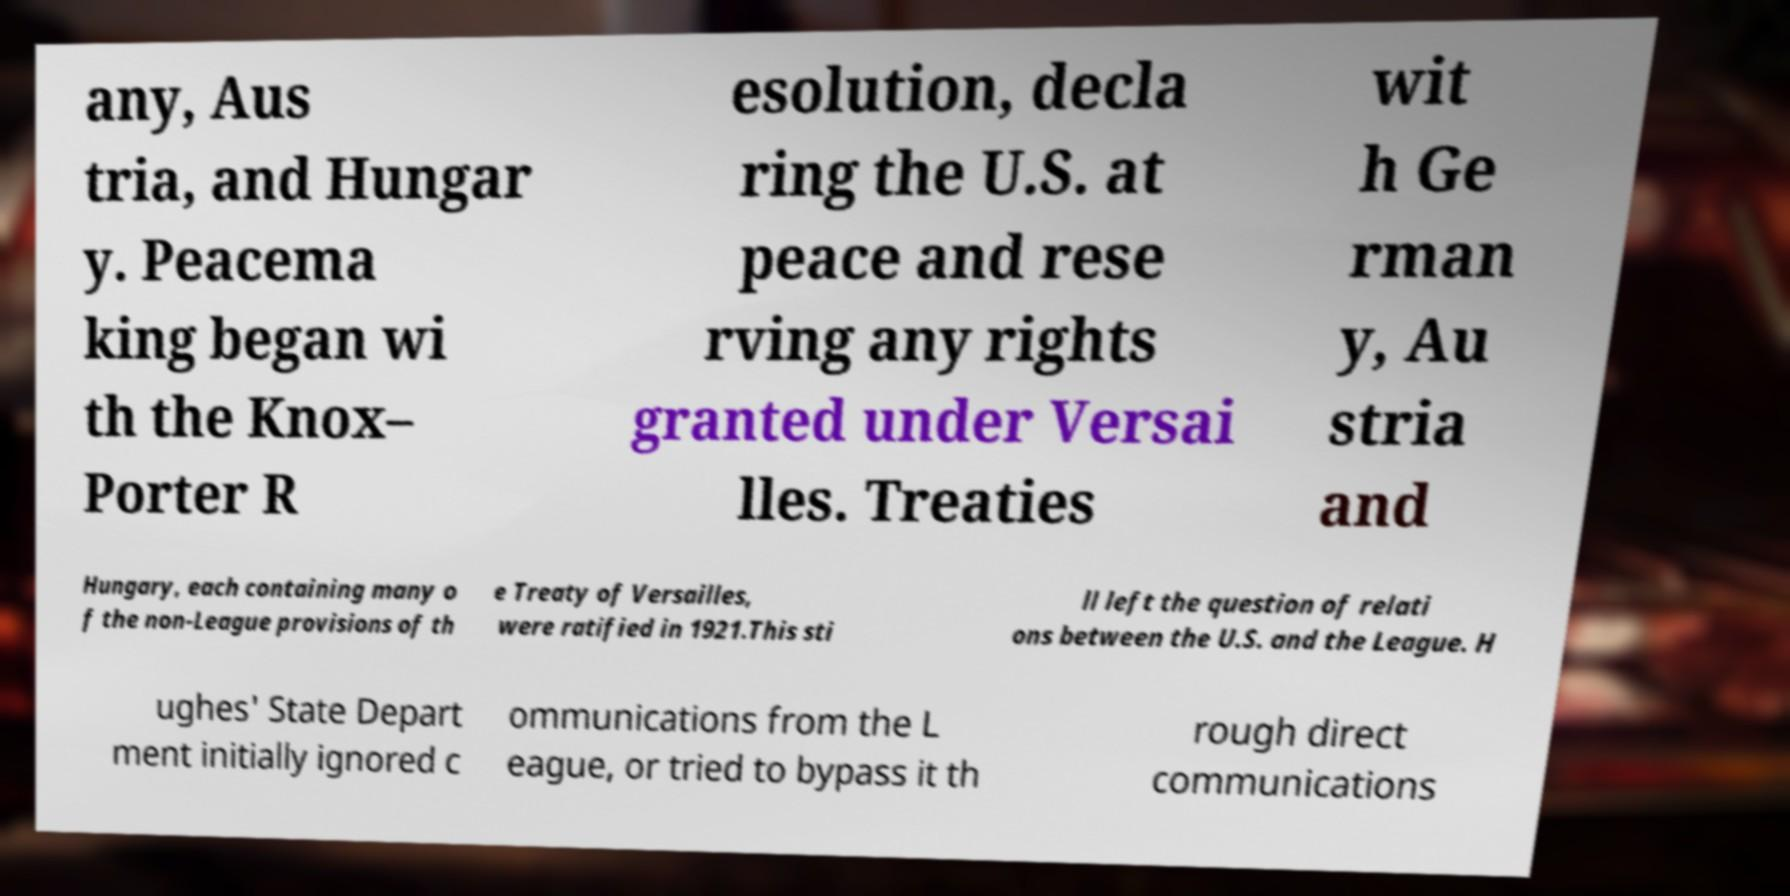I need the written content from this picture converted into text. Can you do that? any, Aus tria, and Hungar y. Peacema king began wi th the Knox– Porter R esolution, decla ring the U.S. at peace and rese rving any rights granted under Versai lles. Treaties wit h Ge rman y, Au stria and Hungary, each containing many o f the non-League provisions of th e Treaty of Versailles, were ratified in 1921.This sti ll left the question of relati ons between the U.S. and the League. H ughes' State Depart ment initially ignored c ommunications from the L eague, or tried to bypass it th rough direct communications 